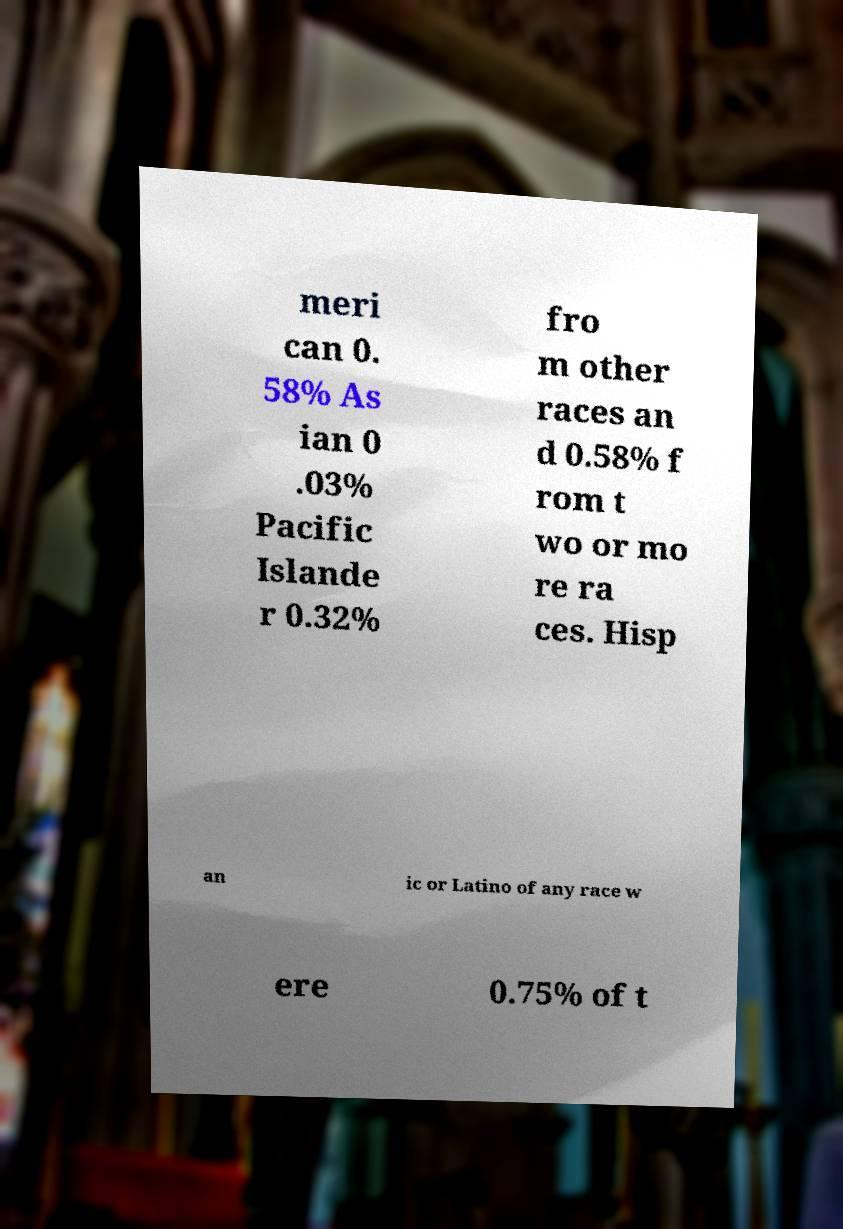Could you extract and type out the text from this image? meri can 0. 58% As ian 0 .03% Pacific Islande r 0.32% fro m other races an d 0.58% f rom t wo or mo re ra ces. Hisp an ic or Latino of any race w ere 0.75% of t 